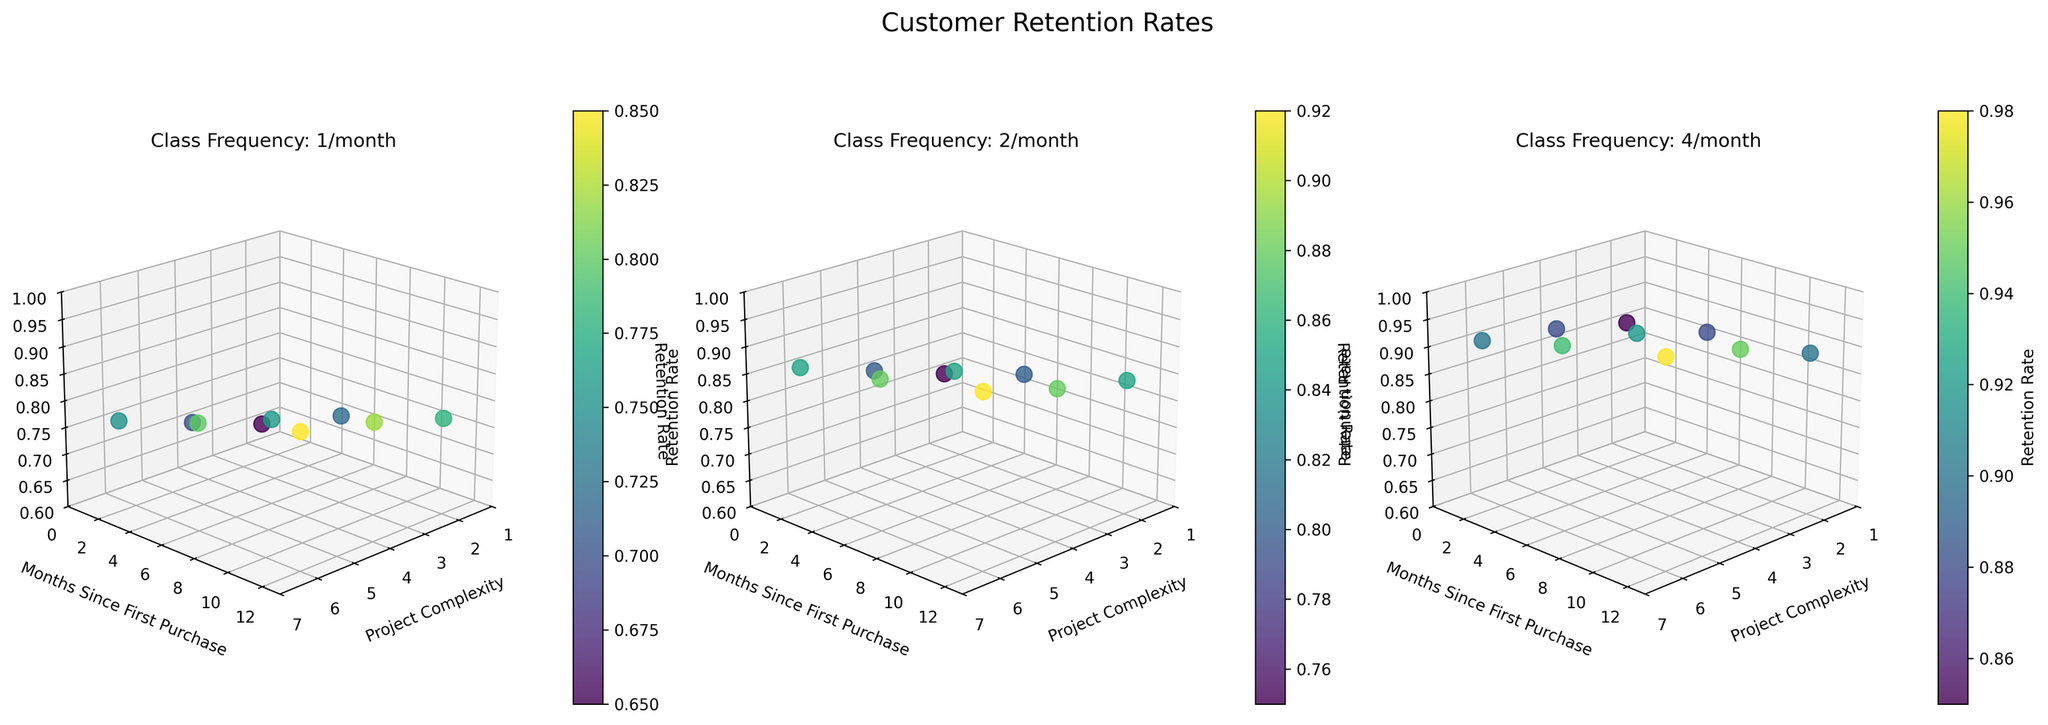What are the axes labeled on the subplots? The axes are labeled as 'Project Complexity' on the x-axis, 'Months Since First Purchase' on the y-axis, and 'Retention Rate' on the z-axis.
Answer: Project Complexity, Months Since First Purchase, Retention Rate How many class frequencies are displayed in the subplots? The subplots display three different class frequencies as indicated by the titles: "Class Frequency: 1/month", "Class Frequency: 2/month", and "Class Frequency: 4/month".
Answer: 3 Which class frequency shows the highest retention rate at a project complexity of 6 and 12 months since the first purchase? In the second and third subplots, the highest retention rates at project complexity 6 and 12 months since the first purchase are presented. By observing, the third subplot with "Class Frequency: 4/month" has the highest retention rate with 0.98.
Answer: Class Frequency: 4/month What is the retention rate for a class frequency of 2/month when the project complexity is 4 and months since the first purchase is 6? In the middle subplot for class frequency 2/month, the point at project complexity 4 and months since the first purchase 6 shows a retention rate of 0.85.
Answer: 0.85 Is the retention rate generally increasing, decreasing, or remaining constant as the project complexity increases at each class frequency level? Observing the plots, it is seen that for all class frequencies, retention rates generally increase as project complexity increases from 2 to 6.
Answer: Increasing How does the retention rate at project complexity 4 compare between class frequencies of 1/month and 4/month at 1 month since the first purchase? The first subplot for 1/month and the third subplot for 4/month show the retention rate at project complexity 4 and 1 month since the first purchase. These rates are 0.70 for 1/month and 0.88 for 4/month.
Answer: 0.70 vs 0.88 What is the general trend of retention rate over time since the first purchase across all three subplots? Across all subplots, the retention rate shows an upward trend as the months since first purchase increase from 1 to 12.
Answer: Increasing Rank the class frequencies from highest to lowest in terms of retention rate at the highest project complexity level (6) at 12 months since the first purchase. At project complexity 6 and 12 months, the subplots show the retention rates. They are 0.85 for 1/month, 0.92 for 2/month, and 0.98 for 4/month. The order from highest to lowest is 4/month, 2/month, 1/month.
Answer: 4/month, 2/month, 1/month What is the color trend associated with higher retention rates on the scatter plots? The scatter plots use a colormap where points with higher retention rates appear in lighter, yellowish colors, and lower rates in darker, bluish colors.
Answer: Lighter colors Does the class frequency of 2/month have any month with a retention rate over 0.9? Observing the middle subplot (2/month), none of the points exceed a retention rate of 0.9, staying at or below 0.88.
Answer: No 